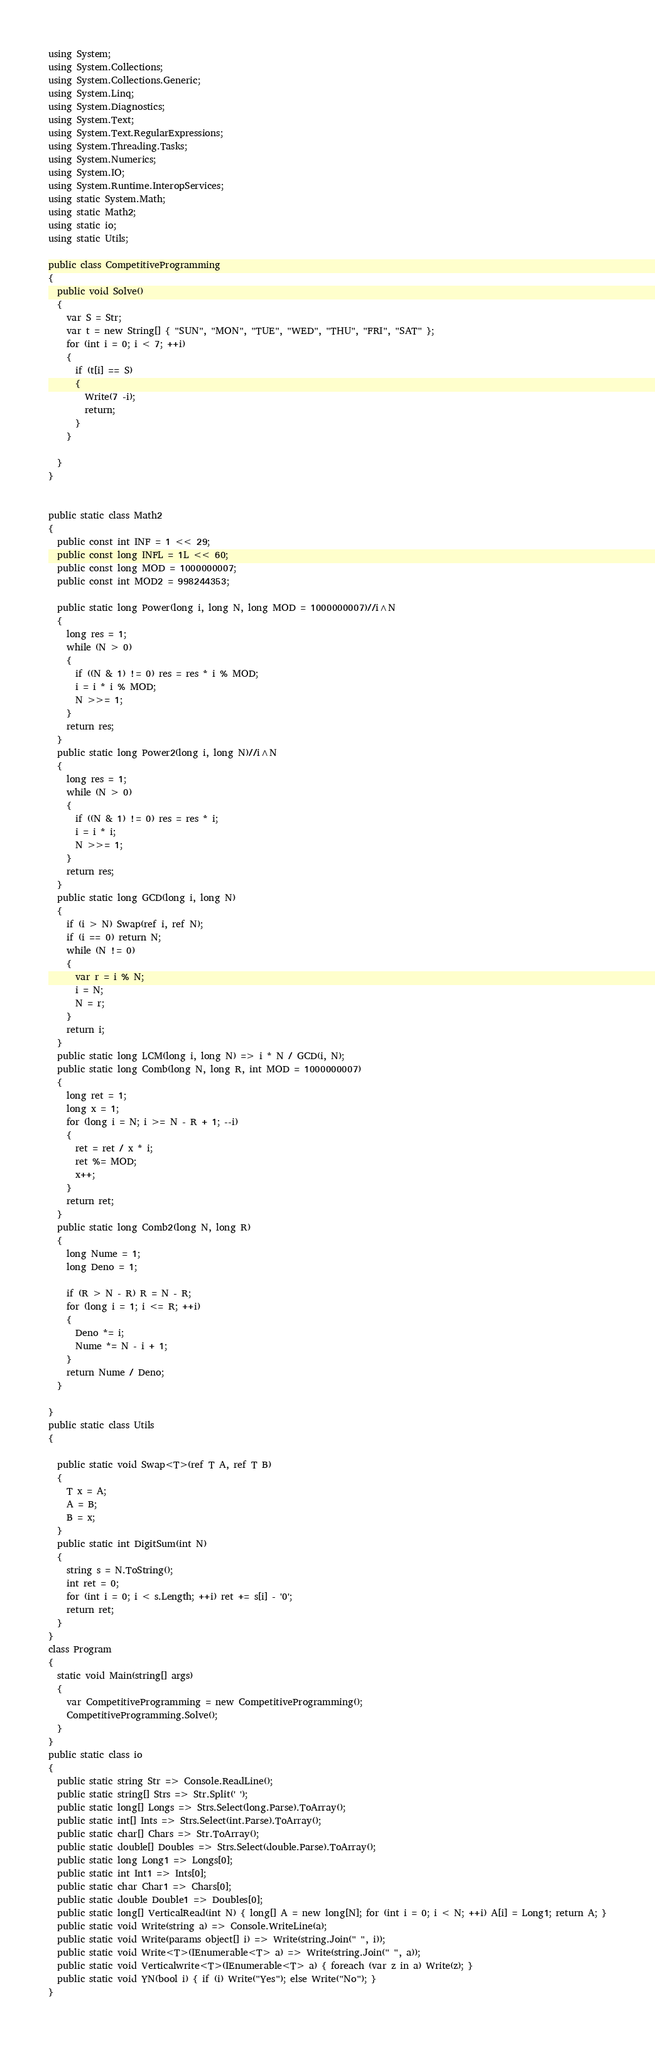Convert code to text. <code><loc_0><loc_0><loc_500><loc_500><_C#_>using System;
using System.Collections;
using System.Collections.Generic;
using System.Linq;
using System.Diagnostics;
using System.Text;
using System.Text.RegularExpressions;
using System.Threading.Tasks;
using System.Numerics;
using System.IO;
using System.Runtime.InteropServices;
using static System.Math;
using static Math2;
using static io;
using static Utils;

public class CompetitiveProgramming
{
  public void Solve()
  {
    var S = Str;
    var t = new String[] { "SUN", "MON", "TUE", "WED", "THU", "FRI", "SAT" };
    for (int i = 0; i < 7; ++i)
    {
      if (t[i] == S)
      {
        Write(7 -i);
        return;
      }
    }

  }
}


public static class Math2
{
  public const int INF = 1 << 29;
  public const long INFL = 1L << 60;
  public const long MOD = 1000000007;
  public const int MOD2 = 998244353;

  public static long Power(long i, long N, long MOD = 1000000007)//i^N
  {
    long res = 1;
    while (N > 0)
    {
      if ((N & 1) != 0) res = res * i % MOD;
      i = i * i % MOD;
      N >>= 1;
    }
    return res;
  }
  public static long Power2(long i, long N)//i^N
  {
    long res = 1;
    while (N > 0)
    {
      if ((N & 1) != 0) res = res * i;
      i = i * i;
      N >>= 1;
    }
    return res;
  }
  public static long GCD(long i, long N)
  {
    if (i > N) Swap(ref i, ref N);
    if (i == 0) return N;
    while (N != 0)
    {
      var r = i % N;
      i = N;
      N = r;
    }
    return i;
  }
  public static long LCM(long i, long N) => i * N / GCD(i, N);
  public static long Comb(long N, long R, int MOD = 1000000007)
  {
    long ret = 1;
    long x = 1;
    for (long i = N; i >= N - R + 1; --i)
    {
      ret = ret / x * i;
      ret %= MOD;
      x++;
    }
    return ret;
  }
  public static long Comb2(long N, long R)
  {
    long Nume = 1;
    long Deno = 1;

    if (R > N - R) R = N - R;
    for (long i = 1; i <= R; ++i)
    {
      Deno *= i;
      Nume *= N - i + 1;
    }
    return Nume / Deno;
  }

}
public static class Utils
{

  public static void Swap<T>(ref T A, ref T B)
  {
    T x = A;
    A = B;
    B = x;
  }
  public static int DigitSum(int N)
  {
    string s = N.ToString();
    int ret = 0;
    for (int i = 0; i < s.Length; ++i) ret += s[i] - '0';
    return ret;
  }
}
class Program
{
  static void Main(string[] args)
  {
    var CompetitiveProgramming = new CompetitiveProgramming();
    CompetitiveProgramming.Solve();
  }
}
public static class io
{
  public static string Str => Console.ReadLine();
  public static string[] Strs => Str.Split(' ');
  public static long[] Longs => Strs.Select(long.Parse).ToArray();
  public static int[] Ints => Strs.Select(int.Parse).ToArray();
  public static char[] Chars => Str.ToArray();
  public static double[] Doubles => Strs.Select(double.Parse).ToArray();
  public static long Long1 => Longs[0];
  public static int Int1 => Ints[0];
  public static char Char1 => Chars[0];
  public static double Double1 => Doubles[0];
  public static long[] VerticalRead(int N) { long[] A = new long[N]; for (int i = 0; i < N; ++i) A[i] = Long1; return A; }
  public static void Write(string a) => Console.WriteLine(a);
  public static void Write(params object[] i) => Write(string.Join(" ", i));
  public static void Write<T>(IEnumerable<T> a) => Write(string.Join(" ", a));
  public static void Verticalwrite<T>(IEnumerable<T> a) { foreach (var z in a) Write(z); }
  public static void YN(bool i) { if (i) Write("Yes"); else Write("No"); }
}
</code> 